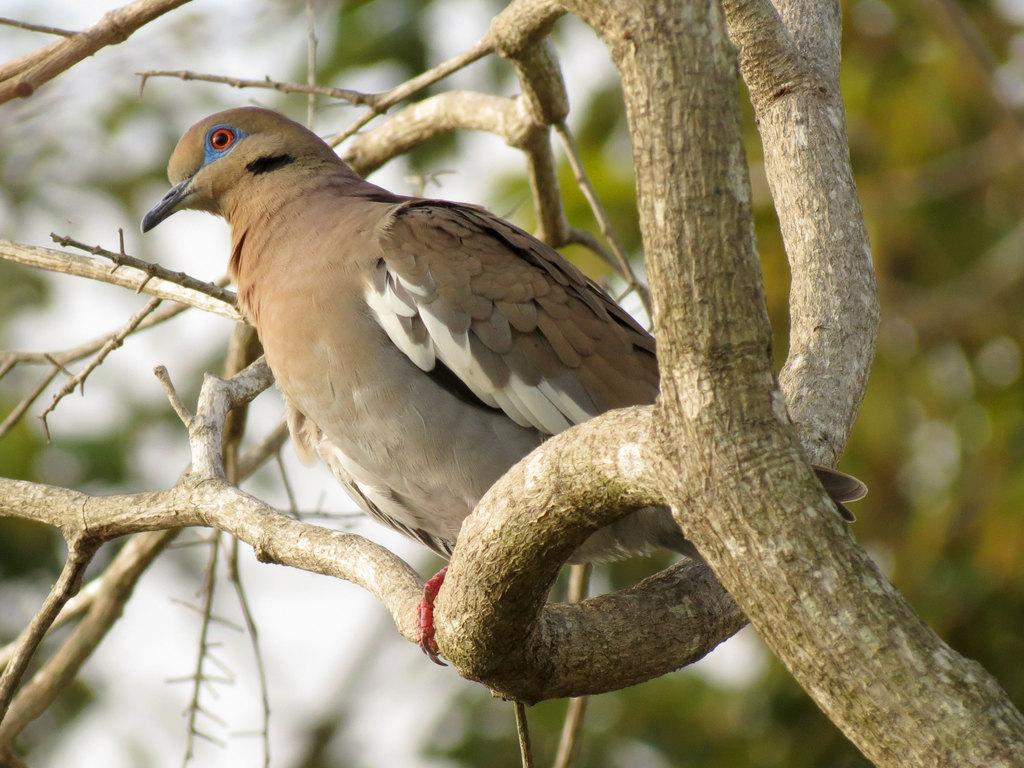What type of animal can be seen in the image? There is a bird in the image. Where is the bird located? The bird is on a branch of a tree. Can you describe the background of the image? The background of the image is blurry. What type of kitty can be seen playing with a banana in the image? There is no kitty or banana present in the image; it features a bird on a tree branch. What angle is the bird sitting at on the tree branch? The angle at which the bird is sitting on the tree branch cannot be determined from the image. 